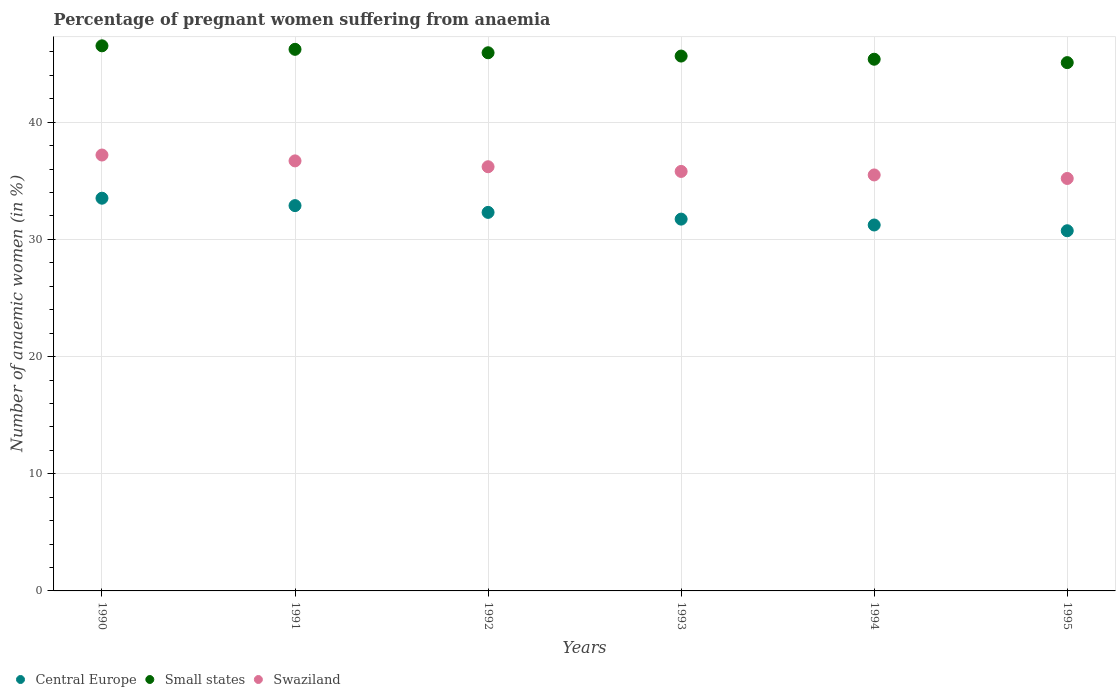How many different coloured dotlines are there?
Make the answer very short. 3. Is the number of dotlines equal to the number of legend labels?
Your answer should be compact. Yes. What is the number of anaemic women in Small states in 1995?
Provide a succinct answer. 45.09. Across all years, what is the maximum number of anaemic women in Central Europe?
Provide a short and direct response. 33.52. Across all years, what is the minimum number of anaemic women in Central Europe?
Your answer should be compact. 30.74. What is the total number of anaemic women in Swaziland in the graph?
Your answer should be compact. 216.6. What is the difference between the number of anaemic women in Central Europe in 1991 and that in 1992?
Your answer should be very brief. 0.58. What is the difference between the number of anaemic women in Central Europe in 1994 and the number of anaemic women in Small states in 1995?
Your response must be concise. -13.86. What is the average number of anaemic women in Central Europe per year?
Your answer should be very brief. 32.07. In the year 1993, what is the difference between the number of anaemic women in Swaziland and number of anaemic women in Small states?
Your answer should be very brief. -9.85. In how many years, is the number of anaemic women in Swaziland greater than 22 %?
Give a very brief answer. 6. What is the ratio of the number of anaemic women in Small states in 1992 to that in 1993?
Ensure brevity in your answer.  1.01. Is the difference between the number of anaemic women in Swaziland in 1991 and 1993 greater than the difference between the number of anaemic women in Small states in 1991 and 1993?
Offer a very short reply. Yes. What is the difference between the highest and the second highest number of anaemic women in Small states?
Your answer should be compact. 0.3. What is the difference between the highest and the lowest number of anaemic women in Central Europe?
Provide a succinct answer. 2.78. Is the sum of the number of anaemic women in Swaziland in 1992 and 1993 greater than the maximum number of anaemic women in Central Europe across all years?
Give a very brief answer. Yes. Is it the case that in every year, the sum of the number of anaemic women in Small states and number of anaemic women in Central Europe  is greater than the number of anaemic women in Swaziland?
Offer a very short reply. Yes. Is the number of anaemic women in Swaziland strictly greater than the number of anaemic women in Central Europe over the years?
Your response must be concise. Yes. Is the number of anaemic women in Central Europe strictly less than the number of anaemic women in Swaziland over the years?
Provide a succinct answer. Yes. How many dotlines are there?
Give a very brief answer. 3. Does the graph contain any zero values?
Keep it short and to the point. No. Does the graph contain grids?
Provide a short and direct response. Yes. What is the title of the graph?
Your answer should be compact. Percentage of pregnant women suffering from anaemia. Does "Vanuatu" appear as one of the legend labels in the graph?
Your response must be concise. No. What is the label or title of the X-axis?
Keep it short and to the point. Years. What is the label or title of the Y-axis?
Make the answer very short. Number of anaemic women (in %). What is the Number of anaemic women (in %) of Central Europe in 1990?
Give a very brief answer. 33.52. What is the Number of anaemic women (in %) in Small states in 1990?
Ensure brevity in your answer.  46.52. What is the Number of anaemic women (in %) of Swaziland in 1990?
Your response must be concise. 37.2. What is the Number of anaemic women (in %) in Central Europe in 1991?
Ensure brevity in your answer.  32.88. What is the Number of anaemic women (in %) of Small states in 1991?
Your answer should be compact. 46.22. What is the Number of anaemic women (in %) of Swaziland in 1991?
Your response must be concise. 36.7. What is the Number of anaemic women (in %) of Central Europe in 1992?
Your answer should be compact. 32.3. What is the Number of anaemic women (in %) in Small states in 1992?
Provide a succinct answer. 45.93. What is the Number of anaemic women (in %) of Swaziland in 1992?
Keep it short and to the point. 36.2. What is the Number of anaemic women (in %) in Central Europe in 1993?
Your answer should be very brief. 31.73. What is the Number of anaemic women (in %) in Small states in 1993?
Provide a succinct answer. 45.65. What is the Number of anaemic women (in %) in Swaziland in 1993?
Offer a terse response. 35.8. What is the Number of anaemic women (in %) of Central Europe in 1994?
Provide a short and direct response. 31.23. What is the Number of anaemic women (in %) in Small states in 1994?
Keep it short and to the point. 45.38. What is the Number of anaemic women (in %) in Swaziland in 1994?
Give a very brief answer. 35.5. What is the Number of anaemic women (in %) of Central Europe in 1995?
Keep it short and to the point. 30.74. What is the Number of anaemic women (in %) in Small states in 1995?
Ensure brevity in your answer.  45.09. What is the Number of anaemic women (in %) in Swaziland in 1995?
Offer a very short reply. 35.2. Across all years, what is the maximum Number of anaemic women (in %) of Central Europe?
Make the answer very short. 33.52. Across all years, what is the maximum Number of anaemic women (in %) of Small states?
Your answer should be very brief. 46.52. Across all years, what is the maximum Number of anaemic women (in %) in Swaziland?
Provide a short and direct response. 37.2. Across all years, what is the minimum Number of anaemic women (in %) of Central Europe?
Provide a short and direct response. 30.74. Across all years, what is the minimum Number of anaemic women (in %) in Small states?
Offer a very short reply. 45.09. Across all years, what is the minimum Number of anaemic women (in %) in Swaziland?
Provide a succinct answer. 35.2. What is the total Number of anaemic women (in %) of Central Europe in the graph?
Make the answer very short. 192.4. What is the total Number of anaemic women (in %) in Small states in the graph?
Provide a short and direct response. 274.78. What is the total Number of anaemic women (in %) in Swaziland in the graph?
Give a very brief answer. 216.6. What is the difference between the Number of anaemic women (in %) in Central Europe in 1990 and that in 1991?
Provide a succinct answer. 0.63. What is the difference between the Number of anaemic women (in %) of Small states in 1990 and that in 1991?
Keep it short and to the point. 0.3. What is the difference between the Number of anaemic women (in %) of Central Europe in 1990 and that in 1992?
Offer a terse response. 1.21. What is the difference between the Number of anaemic women (in %) of Small states in 1990 and that in 1992?
Provide a succinct answer. 0.59. What is the difference between the Number of anaemic women (in %) in Central Europe in 1990 and that in 1993?
Keep it short and to the point. 1.78. What is the difference between the Number of anaemic women (in %) in Small states in 1990 and that in 1993?
Your answer should be very brief. 0.87. What is the difference between the Number of anaemic women (in %) in Central Europe in 1990 and that in 1994?
Your answer should be very brief. 2.29. What is the difference between the Number of anaemic women (in %) of Small states in 1990 and that in 1994?
Provide a succinct answer. 1.14. What is the difference between the Number of anaemic women (in %) in Central Europe in 1990 and that in 1995?
Give a very brief answer. 2.78. What is the difference between the Number of anaemic women (in %) of Small states in 1990 and that in 1995?
Give a very brief answer. 1.43. What is the difference between the Number of anaemic women (in %) of Central Europe in 1991 and that in 1992?
Your response must be concise. 0.58. What is the difference between the Number of anaemic women (in %) of Small states in 1991 and that in 1992?
Your response must be concise. 0.29. What is the difference between the Number of anaemic women (in %) in Central Europe in 1991 and that in 1993?
Provide a succinct answer. 1.15. What is the difference between the Number of anaemic women (in %) of Small states in 1991 and that in 1993?
Keep it short and to the point. 0.57. What is the difference between the Number of anaemic women (in %) in Central Europe in 1991 and that in 1994?
Provide a short and direct response. 1.65. What is the difference between the Number of anaemic women (in %) of Small states in 1991 and that in 1994?
Keep it short and to the point. 0.85. What is the difference between the Number of anaemic women (in %) of Swaziland in 1991 and that in 1994?
Offer a very short reply. 1.2. What is the difference between the Number of anaemic women (in %) of Central Europe in 1991 and that in 1995?
Offer a very short reply. 2.14. What is the difference between the Number of anaemic women (in %) of Small states in 1991 and that in 1995?
Your answer should be compact. 1.13. What is the difference between the Number of anaemic women (in %) of Central Europe in 1992 and that in 1993?
Offer a terse response. 0.57. What is the difference between the Number of anaemic women (in %) in Small states in 1992 and that in 1993?
Provide a short and direct response. 0.28. What is the difference between the Number of anaemic women (in %) in Central Europe in 1992 and that in 1994?
Provide a short and direct response. 1.08. What is the difference between the Number of anaemic women (in %) of Small states in 1992 and that in 1994?
Provide a succinct answer. 0.55. What is the difference between the Number of anaemic women (in %) of Swaziland in 1992 and that in 1994?
Make the answer very short. 0.7. What is the difference between the Number of anaemic women (in %) in Central Europe in 1992 and that in 1995?
Make the answer very short. 1.57. What is the difference between the Number of anaemic women (in %) in Small states in 1992 and that in 1995?
Ensure brevity in your answer.  0.84. What is the difference between the Number of anaemic women (in %) in Swaziland in 1992 and that in 1995?
Keep it short and to the point. 1. What is the difference between the Number of anaemic women (in %) in Central Europe in 1993 and that in 1994?
Keep it short and to the point. 0.5. What is the difference between the Number of anaemic women (in %) in Small states in 1993 and that in 1994?
Ensure brevity in your answer.  0.27. What is the difference between the Number of anaemic women (in %) of Small states in 1993 and that in 1995?
Make the answer very short. 0.56. What is the difference between the Number of anaemic women (in %) of Central Europe in 1994 and that in 1995?
Make the answer very short. 0.49. What is the difference between the Number of anaemic women (in %) of Small states in 1994 and that in 1995?
Provide a succinct answer. 0.29. What is the difference between the Number of anaemic women (in %) of Central Europe in 1990 and the Number of anaemic women (in %) of Small states in 1991?
Offer a terse response. -12.71. What is the difference between the Number of anaemic women (in %) of Central Europe in 1990 and the Number of anaemic women (in %) of Swaziland in 1991?
Keep it short and to the point. -3.18. What is the difference between the Number of anaemic women (in %) of Small states in 1990 and the Number of anaemic women (in %) of Swaziland in 1991?
Keep it short and to the point. 9.82. What is the difference between the Number of anaemic women (in %) in Central Europe in 1990 and the Number of anaemic women (in %) in Small states in 1992?
Keep it short and to the point. -12.41. What is the difference between the Number of anaemic women (in %) in Central Europe in 1990 and the Number of anaemic women (in %) in Swaziland in 1992?
Make the answer very short. -2.68. What is the difference between the Number of anaemic women (in %) in Small states in 1990 and the Number of anaemic women (in %) in Swaziland in 1992?
Keep it short and to the point. 10.32. What is the difference between the Number of anaemic women (in %) in Central Europe in 1990 and the Number of anaemic women (in %) in Small states in 1993?
Keep it short and to the point. -12.13. What is the difference between the Number of anaemic women (in %) of Central Europe in 1990 and the Number of anaemic women (in %) of Swaziland in 1993?
Offer a terse response. -2.28. What is the difference between the Number of anaemic women (in %) of Small states in 1990 and the Number of anaemic women (in %) of Swaziland in 1993?
Your answer should be compact. 10.72. What is the difference between the Number of anaemic women (in %) of Central Europe in 1990 and the Number of anaemic women (in %) of Small states in 1994?
Offer a terse response. -11.86. What is the difference between the Number of anaemic women (in %) of Central Europe in 1990 and the Number of anaemic women (in %) of Swaziland in 1994?
Give a very brief answer. -1.98. What is the difference between the Number of anaemic women (in %) in Small states in 1990 and the Number of anaemic women (in %) in Swaziland in 1994?
Offer a terse response. 11.02. What is the difference between the Number of anaemic women (in %) in Central Europe in 1990 and the Number of anaemic women (in %) in Small states in 1995?
Make the answer very short. -11.57. What is the difference between the Number of anaemic women (in %) in Central Europe in 1990 and the Number of anaemic women (in %) in Swaziland in 1995?
Provide a short and direct response. -1.68. What is the difference between the Number of anaemic women (in %) in Small states in 1990 and the Number of anaemic women (in %) in Swaziland in 1995?
Ensure brevity in your answer.  11.32. What is the difference between the Number of anaemic women (in %) in Central Europe in 1991 and the Number of anaemic women (in %) in Small states in 1992?
Your answer should be very brief. -13.04. What is the difference between the Number of anaemic women (in %) of Central Europe in 1991 and the Number of anaemic women (in %) of Swaziland in 1992?
Offer a very short reply. -3.32. What is the difference between the Number of anaemic women (in %) in Small states in 1991 and the Number of anaemic women (in %) in Swaziland in 1992?
Your answer should be very brief. 10.02. What is the difference between the Number of anaemic women (in %) in Central Europe in 1991 and the Number of anaemic women (in %) in Small states in 1993?
Offer a very short reply. -12.76. What is the difference between the Number of anaemic women (in %) in Central Europe in 1991 and the Number of anaemic women (in %) in Swaziland in 1993?
Your response must be concise. -2.92. What is the difference between the Number of anaemic women (in %) of Small states in 1991 and the Number of anaemic women (in %) of Swaziland in 1993?
Offer a very short reply. 10.42. What is the difference between the Number of anaemic women (in %) in Central Europe in 1991 and the Number of anaemic women (in %) in Small states in 1994?
Give a very brief answer. -12.49. What is the difference between the Number of anaemic women (in %) of Central Europe in 1991 and the Number of anaemic women (in %) of Swaziland in 1994?
Your answer should be very brief. -2.62. What is the difference between the Number of anaemic women (in %) of Small states in 1991 and the Number of anaemic women (in %) of Swaziland in 1994?
Ensure brevity in your answer.  10.72. What is the difference between the Number of anaemic women (in %) of Central Europe in 1991 and the Number of anaemic women (in %) of Small states in 1995?
Offer a terse response. -12.2. What is the difference between the Number of anaemic women (in %) in Central Europe in 1991 and the Number of anaemic women (in %) in Swaziland in 1995?
Offer a terse response. -2.32. What is the difference between the Number of anaemic women (in %) of Small states in 1991 and the Number of anaemic women (in %) of Swaziland in 1995?
Your response must be concise. 11.02. What is the difference between the Number of anaemic women (in %) in Central Europe in 1992 and the Number of anaemic women (in %) in Small states in 1993?
Your response must be concise. -13.34. What is the difference between the Number of anaemic women (in %) in Central Europe in 1992 and the Number of anaemic women (in %) in Swaziland in 1993?
Provide a short and direct response. -3.5. What is the difference between the Number of anaemic women (in %) of Small states in 1992 and the Number of anaemic women (in %) of Swaziland in 1993?
Provide a short and direct response. 10.13. What is the difference between the Number of anaemic women (in %) in Central Europe in 1992 and the Number of anaemic women (in %) in Small states in 1994?
Offer a terse response. -13.07. What is the difference between the Number of anaemic women (in %) of Central Europe in 1992 and the Number of anaemic women (in %) of Swaziland in 1994?
Provide a succinct answer. -3.2. What is the difference between the Number of anaemic women (in %) in Small states in 1992 and the Number of anaemic women (in %) in Swaziland in 1994?
Your response must be concise. 10.43. What is the difference between the Number of anaemic women (in %) in Central Europe in 1992 and the Number of anaemic women (in %) in Small states in 1995?
Your answer should be very brief. -12.78. What is the difference between the Number of anaemic women (in %) of Central Europe in 1992 and the Number of anaemic women (in %) of Swaziland in 1995?
Your answer should be compact. -2.9. What is the difference between the Number of anaemic women (in %) of Small states in 1992 and the Number of anaemic women (in %) of Swaziland in 1995?
Make the answer very short. 10.73. What is the difference between the Number of anaemic women (in %) of Central Europe in 1993 and the Number of anaemic women (in %) of Small states in 1994?
Keep it short and to the point. -13.65. What is the difference between the Number of anaemic women (in %) in Central Europe in 1993 and the Number of anaemic women (in %) in Swaziland in 1994?
Provide a succinct answer. -3.77. What is the difference between the Number of anaemic women (in %) in Small states in 1993 and the Number of anaemic women (in %) in Swaziland in 1994?
Give a very brief answer. 10.15. What is the difference between the Number of anaemic women (in %) of Central Europe in 1993 and the Number of anaemic women (in %) of Small states in 1995?
Provide a succinct answer. -13.36. What is the difference between the Number of anaemic women (in %) in Central Europe in 1993 and the Number of anaemic women (in %) in Swaziland in 1995?
Provide a succinct answer. -3.47. What is the difference between the Number of anaemic women (in %) of Small states in 1993 and the Number of anaemic women (in %) of Swaziland in 1995?
Ensure brevity in your answer.  10.45. What is the difference between the Number of anaemic women (in %) of Central Europe in 1994 and the Number of anaemic women (in %) of Small states in 1995?
Your answer should be very brief. -13.86. What is the difference between the Number of anaemic women (in %) of Central Europe in 1994 and the Number of anaemic women (in %) of Swaziland in 1995?
Offer a very short reply. -3.97. What is the difference between the Number of anaemic women (in %) of Small states in 1994 and the Number of anaemic women (in %) of Swaziland in 1995?
Offer a terse response. 10.18. What is the average Number of anaemic women (in %) in Central Europe per year?
Your answer should be compact. 32.07. What is the average Number of anaemic women (in %) of Small states per year?
Provide a short and direct response. 45.8. What is the average Number of anaemic women (in %) in Swaziland per year?
Provide a short and direct response. 36.1. In the year 1990, what is the difference between the Number of anaemic women (in %) in Central Europe and Number of anaemic women (in %) in Small states?
Your response must be concise. -13. In the year 1990, what is the difference between the Number of anaemic women (in %) of Central Europe and Number of anaemic women (in %) of Swaziland?
Offer a terse response. -3.68. In the year 1990, what is the difference between the Number of anaemic women (in %) of Small states and Number of anaemic women (in %) of Swaziland?
Offer a very short reply. 9.32. In the year 1991, what is the difference between the Number of anaemic women (in %) of Central Europe and Number of anaemic women (in %) of Small states?
Give a very brief answer. -13.34. In the year 1991, what is the difference between the Number of anaemic women (in %) in Central Europe and Number of anaemic women (in %) in Swaziland?
Give a very brief answer. -3.82. In the year 1991, what is the difference between the Number of anaemic women (in %) in Small states and Number of anaemic women (in %) in Swaziland?
Provide a succinct answer. 9.52. In the year 1992, what is the difference between the Number of anaemic women (in %) in Central Europe and Number of anaemic women (in %) in Small states?
Provide a short and direct response. -13.62. In the year 1992, what is the difference between the Number of anaemic women (in %) in Central Europe and Number of anaemic women (in %) in Swaziland?
Your answer should be very brief. -3.9. In the year 1992, what is the difference between the Number of anaemic women (in %) in Small states and Number of anaemic women (in %) in Swaziland?
Ensure brevity in your answer.  9.73. In the year 1993, what is the difference between the Number of anaemic women (in %) in Central Europe and Number of anaemic women (in %) in Small states?
Your answer should be very brief. -13.92. In the year 1993, what is the difference between the Number of anaemic women (in %) in Central Europe and Number of anaemic women (in %) in Swaziland?
Your answer should be compact. -4.07. In the year 1993, what is the difference between the Number of anaemic women (in %) in Small states and Number of anaemic women (in %) in Swaziland?
Ensure brevity in your answer.  9.85. In the year 1994, what is the difference between the Number of anaemic women (in %) in Central Europe and Number of anaemic women (in %) in Small states?
Ensure brevity in your answer.  -14.15. In the year 1994, what is the difference between the Number of anaemic women (in %) of Central Europe and Number of anaemic women (in %) of Swaziland?
Your response must be concise. -4.27. In the year 1994, what is the difference between the Number of anaemic women (in %) of Small states and Number of anaemic women (in %) of Swaziland?
Give a very brief answer. 9.88. In the year 1995, what is the difference between the Number of anaemic women (in %) of Central Europe and Number of anaemic women (in %) of Small states?
Your answer should be very brief. -14.35. In the year 1995, what is the difference between the Number of anaemic women (in %) in Central Europe and Number of anaemic women (in %) in Swaziland?
Provide a short and direct response. -4.46. In the year 1995, what is the difference between the Number of anaemic women (in %) in Small states and Number of anaemic women (in %) in Swaziland?
Your answer should be compact. 9.89. What is the ratio of the Number of anaemic women (in %) of Central Europe in 1990 to that in 1991?
Ensure brevity in your answer.  1.02. What is the ratio of the Number of anaemic women (in %) in Small states in 1990 to that in 1991?
Your answer should be compact. 1.01. What is the ratio of the Number of anaemic women (in %) of Swaziland in 1990 to that in 1991?
Your response must be concise. 1.01. What is the ratio of the Number of anaemic women (in %) in Central Europe in 1990 to that in 1992?
Provide a succinct answer. 1.04. What is the ratio of the Number of anaemic women (in %) in Small states in 1990 to that in 1992?
Give a very brief answer. 1.01. What is the ratio of the Number of anaemic women (in %) in Swaziland in 1990 to that in 1992?
Keep it short and to the point. 1.03. What is the ratio of the Number of anaemic women (in %) of Central Europe in 1990 to that in 1993?
Give a very brief answer. 1.06. What is the ratio of the Number of anaemic women (in %) of Small states in 1990 to that in 1993?
Your answer should be compact. 1.02. What is the ratio of the Number of anaemic women (in %) of Swaziland in 1990 to that in 1993?
Provide a succinct answer. 1.04. What is the ratio of the Number of anaemic women (in %) in Central Europe in 1990 to that in 1994?
Provide a short and direct response. 1.07. What is the ratio of the Number of anaemic women (in %) of Small states in 1990 to that in 1994?
Ensure brevity in your answer.  1.03. What is the ratio of the Number of anaemic women (in %) in Swaziland in 1990 to that in 1994?
Provide a succinct answer. 1.05. What is the ratio of the Number of anaemic women (in %) in Central Europe in 1990 to that in 1995?
Make the answer very short. 1.09. What is the ratio of the Number of anaemic women (in %) in Small states in 1990 to that in 1995?
Your answer should be very brief. 1.03. What is the ratio of the Number of anaemic women (in %) of Swaziland in 1990 to that in 1995?
Your answer should be compact. 1.06. What is the ratio of the Number of anaemic women (in %) of Central Europe in 1991 to that in 1992?
Offer a terse response. 1.02. What is the ratio of the Number of anaemic women (in %) in Small states in 1991 to that in 1992?
Provide a succinct answer. 1.01. What is the ratio of the Number of anaemic women (in %) in Swaziland in 1991 to that in 1992?
Your response must be concise. 1.01. What is the ratio of the Number of anaemic women (in %) in Central Europe in 1991 to that in 1993?
Your answer should be compact. 1.04. What is the ratio of the Number of anaemic women (in %) in Small states in 1991 to that in 1993?
Ensure brevity in your answer.  1.01. What is the ratio of the Number of anaemic women (in %) of Swaziland in 1991 to that in 1993?
Your response must be concise. 1.03. What is the ratio of the Number of anaemic women (in %) in Central Europe in 1991 to that in 1994?
Offer a very short reply. 1.05. What is the ratio of the Number of anaemic women (in %) of Small states in 1991 to that in 1994?
Give a very brief answer. 1.02. What is the ratio of the Number of anaemic women (in %) of Swaziland in 1991 to that in 1994?
Ensure brevity in your answer.  1.03. What is the ratio of the Number of anaemic women (in %) in Central Europe in 1991 to that in 1995?
Keep it short and to the point. 1.07. What is the ratio of the Number of anaemic women (in %) of Small states in 1991 to that in 1995?
Offer a very short reply. 1.03. What is the ratio of the Number of anaemic women (in %) in Swaziland in 1991 to that in 1995?
Your answer should be compact. 1.04. What is the ratio of the Number of anaemic women (in %) in Central Europe in 1992 to that in 1993?
Make the answer very short. 1.02. What is the ratio of the Number of anaemic women (in %) in Swaziland in 1992 to that in 1993?
Your response must be concise. 1.01. What is the ratio of the Number of anaemic women (in %) in Central Europe in 1992 to that in 1994?
Ensure brevity in your answer.  1.03. What is the ratio of the Number of anaemic women (in %) of Small states in 1992 to that in 1994?
Your response must be concise. 1.01. What is the ratio of the Number of anaemic women (in %) of Swaziland in 1992 to that in 1994?
Provide a short and direct response. 1.02. What is the ratio of the Number of anaemic women (in %) of Central Europe in 1992 to that in 1995?
Your answer should be compact. 1.05. What is the ratio of the Number of anaemic women (in %) of Small states in 1992 to that in 1995?
Offer a terse response. 1.02. What is the ratio of the Number of anaemic women (in %) in Swaziland in 1992 to that in 1995?
Provide a short and direct response. 1.03. What is the ratio of the Number of anaemic women (in %) of Central Europe in 1993 to that in 1994?
Make the answer very short. 1.02. What is the ratio of the Number of anaemic women (in %) of Small states in 1993 to that in 1994?
Ensure brevity in your answer.  1.01. What is the ratio of the Number of anaemic women (in %) of Swaziland in 1993 to that in 1994?
Make the answer very short. 1.01. What is the ratio of the Number of anaemic women (in %) in Central Europe in 1993 to that in 1995?
Your answer should be very brief. 1.03. What is the ratio of the Number of anaemic women (in %) of Small states in 1993 to that in 1995?
Offer a very short reply. 1.01. What is the ratio of the Number of anaemic women (in %) of Swaziland in 1993 to that in 1995?
Keep it short and to the point. 1.02. What is the ratio of the Number of anaemic women (in %) in Central Europe in 1994 to that in 1995?
Offer a very short reply. 1.02. What is the ratio of the Number of anaemic women (in %) of Small states in 1994 to that in 1995?
Offer a terse response. 1.01. What is the ratio of the Number of anaemic women (in %) of Swaziland in 1994 to that in 1995?
Provide a succinct answer. 1.01. What is the difference between the highest and the second highest Number of anaemic women (in %) of Central Europe?
Offer a terse response. 0.63. What is the difference between the highest and the second highest Number of anaemic women (in %) of Small states?
Keep it short and to the point. 0.3. What is the difference between the highest and the second highest Number of anaemic women (in %) in Swaziland?
Offer a very short reply. 0.5. What is the difference between the highest and the lowest Number of anaemic women (in %) in Central Europe?
Ensure brevity in your answer.  2.78. What is the difference between the highest and the lowest Number of anaemic women (in %) of Small states?
Your response must be concise. 1.43. 